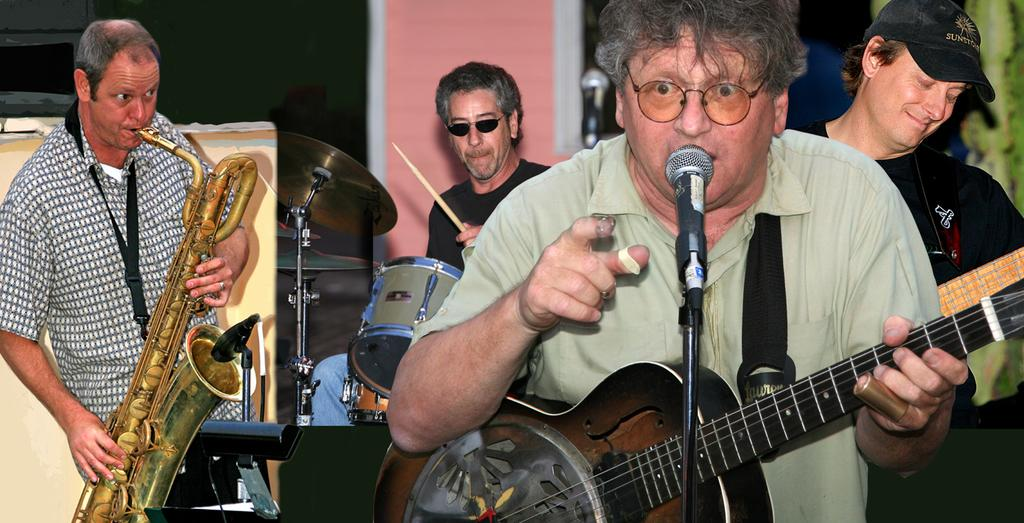How many people are in the image? There are four persons in the image. What are the people in the image doing? Each person is playing a musical instrument. Can you identify the specific instruments being played? One person is playing a guitar, one person is playing drums, one person is playing a saxophone, and one person is singing on a microphone. What is visible in the background of the image? There is a wall visible in the background of the image. What type of books can be seen on the wall in the image? There are no books visible on the wall in the image; only a wall is present in the background. 